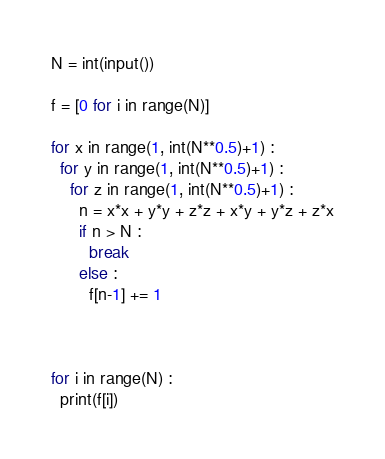<code> <loc_0><loc_0><loc_500><loc_500><_Python_>N = int(input())

f = [0 for i in range(N)]

for x in range(1, int(N**0.5)+1) :
  for y in range(1, int(N**0.5)+1) :
    for z in range(1, int(N**0.5)+1) :
      n = x*x + y*y + z*z + x*y + y*z + z*x
      if n > N :
        break
      else :
        f[n-1] += 1
        
        
        
for i in range(N) :
  print(f[i])</code> 